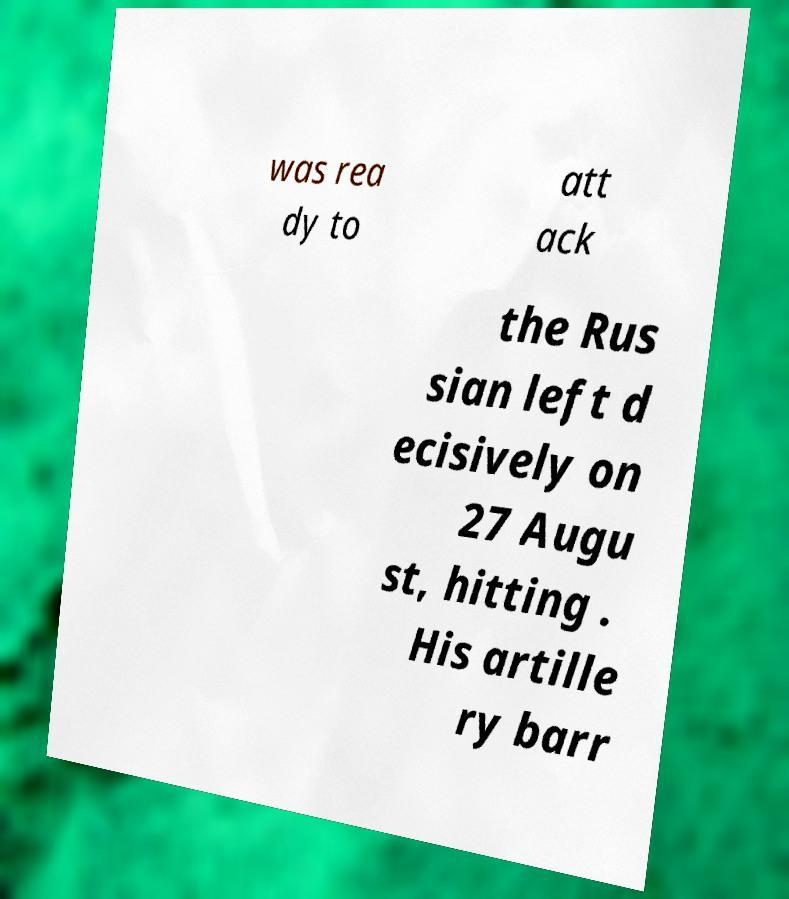For documentation purposes, I need the text within this image transcribed. Could you provide that? was rea dy to att ack the Rus sian left d ecisively on 27 Augu st, hitting . His artille ry barr 